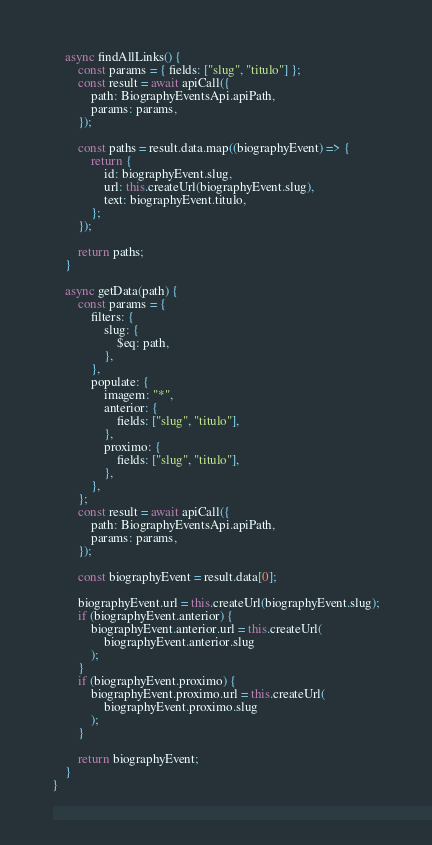Convert code to text. <code><loc_0><loc_0><loc_500><loc_500><_JavaScript_>
    async findAllLinks() {
        const params = { fields: ["slug", "titulo"] };
        const result = await apiCall({
            path: BiographyEventsApi.apiPath,
            params: params,
        });

        const paths = result.data.map((biographyEvent) => {
            return {
                id: biographyEvent.slug,
                url: this.createUrl(biographyEvent.slug),
                text: biographyEvent.titulo,
            };
        });

        return paths;
    }

    async getData(path) {
        const params = {
            filters: {
                slug: {
                    $eq: path,
                },
            },
            populate: {
                imagem: "*",
                anterior: {
                    fields: ["slug", "titulo"],
                },
                proximo: {
                    fields: ["slug", "titulo"],
                },
            },
        };
        const result = await apiCall({
            path: BiographyEventsApi.apiPath,
            params: params,
        });

        const biographyEvent = result.data[0];

        biographyEvent.url = this.createUrl(biographyEvent.slug);
        if (biographyEvent.anterior) {
            biographyEvent.anterior.url = this.createUrl(
                biographyEvent.anterior.slug
            );
        }
        if (biographyEvent.proximo) {
            biographyEvent.proximo.url = this.createUrl(
                biographyEvent.proximo.slug
            );
        }

        return biographyEvent;
    }
}
</code> 